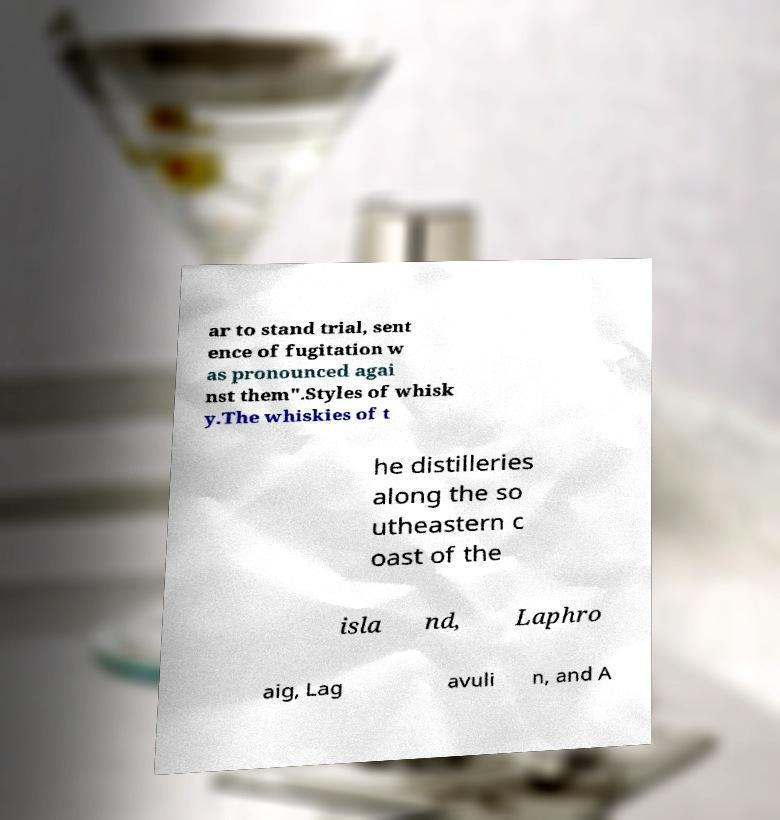Could you extract and type out the text from this image? ar to stand trial, sent ence of fugitation w as pronounced agai nst them".Styles of whisk y.The whiskies of t he distilleries along the so utheastern c oast of the isla nd, Laphro aig, Lag avuli n, and A 